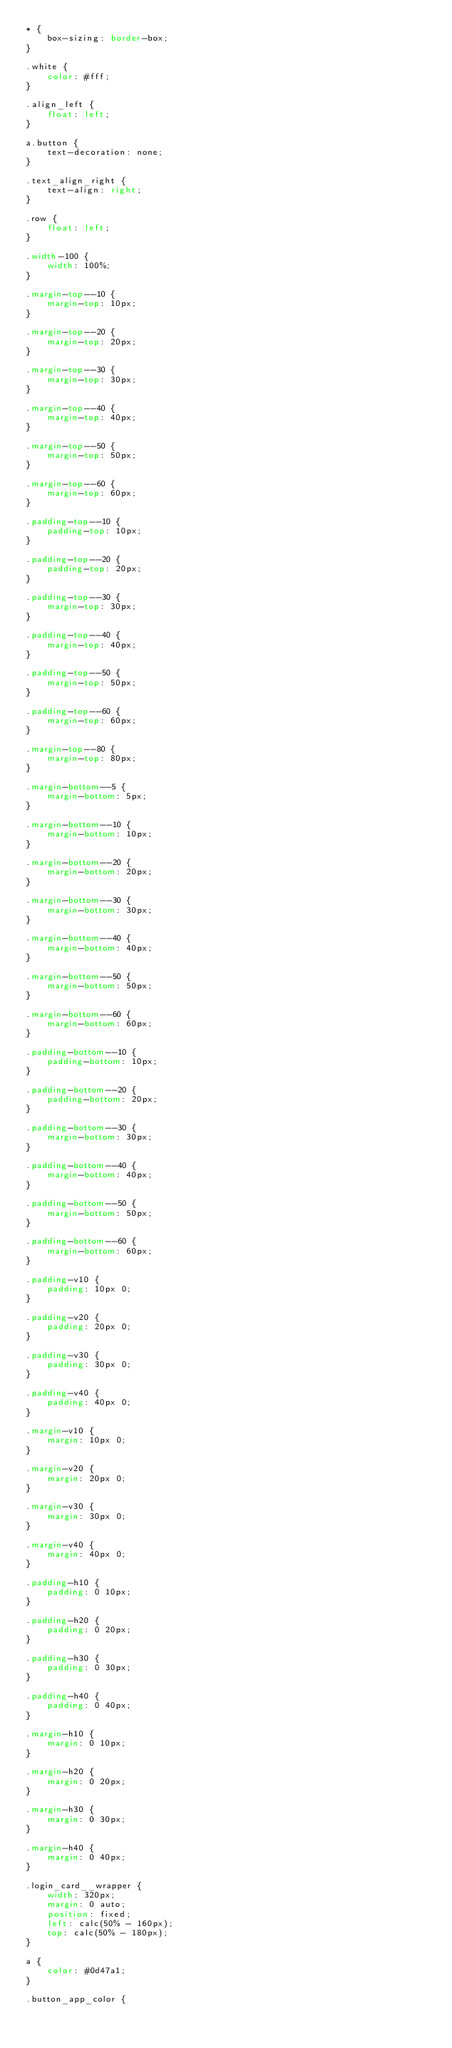Convert code to text. <code><loc_0><loc_0><loc_500><loc_500><_CSS_>* {
    box-sizing: border-box;
}

.white {
    color: #fff;
}

.align_left {
    float: left;
}

a.button {
    text-decoration: none;
}

.text_align_right {
    text-align: right;
}

.row {
    float: left;
}

.width-100 {
    width: 100%;
}

.margin-top--10 {
    margin-top: 10px;
}

.margin-top--20 {
    margin-top: 20px;
}

.margin-top--30 {
    margin-top: 30px;
}

.margin-top--40 {
    margin-top: 40px;
}

.margin-top--50 {
    margin-top: 50px;
}

.margin-top--60 {
    margin-top: 60px;
}

.padding-top--10 {
    padding-top: 10px;
}

.padding-top--20 {
    padding-top: 20px;
}

.padding-top--30 {
    margin-top: 30px;
}

.padding-top--40 {
    margin-top: 40px;
}

.padding-top--50 {
    margin-top: 50px;
}

.padding-top--60 {
    margin-top: 60px;
}

.margin-top--80 {
    margin-top: 80px;
}

.margin-bottom--5 {
    margin-bottom: 5px;
}

.margin-bottom--10 {
    margin-bottom: 10px;
}

.margin-bottom--20 {
    margin-bottom: 20px;
}

.margin-bottom--30 {
    margin-bottom: 30px;
}

.margin-bottom--40 {
    margin-bottom: 40px;
}

.margin-bottom--50 {
    margin-bottom: 50px;
}

.margin-bottom--60 {
    margin-bottom: 60px;
}

.padding-bottom--10 {
    padding-bottom: 10px;
}

.padding-bottom--20 {
    padding-bottom: 20px;
}

.padding-bottom--30 {
    margin-bottom: 30px;
}

.padding-bottom--40 {
    margin-bottom: 40px;
}

.padding-bottom--50 {
    margin-bottom: 50px;
}

.padding-bottom--60 {
    margin-bottom: 60px;
}

.padding-v10 {
    padding: 10px 0;
}

.padding-v20 {
    padding: 20px 0;
}

.padding-v30 {
    padding: 30px 0;
}

.padding-v40 {
    padding: 40px 0;
}

.margin-v10 {
    margin: 10px 0;
}

.margin-v20 {
    margin: 20px 0;
}

.margin-v30 {
    margin: 30px 0;
}

.margin-v40 {
    margin: 40px 0;
}

.padding-h10 {
    padding: 0 10px;
}

.padding-h20 {
    padding: 0 20px;
}

.padding-h30 {
    padding: 0 30px;
}

.padding-h40 {
    padding: 0 40px;
}

.margin-h10 {
    margin: 0 10px;
}

.margin-h20 {
    margin: 0 20px;
}

.margin-h30 {
    margin: 0 30px;
}

.margin-h40 {
    margin: 0 40px;
}

.login_card__wrapper {
    width: 320px;
    margin: 0 auto;
    position: fixed;
    left: calc(50% - 160px);
    top: calc(50% - 180px);
}

a {
    color: #0d47a1;
}

.button_app_color {</code> 